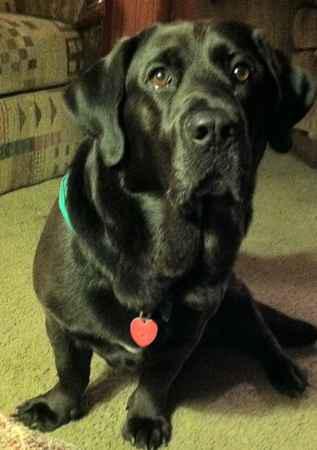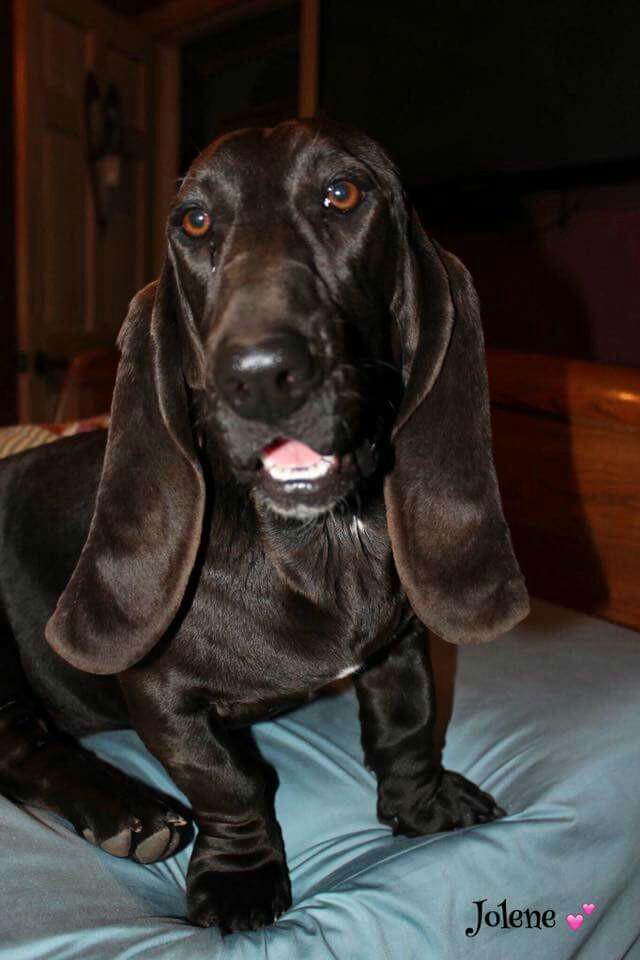The first image is the image on the left, the second image is the image on the right. For the images shown, is this caption "One of the dogs is sitting on or lying next to a pillow." true? Answer yes or no. Yes. The first image is the image on the left, the second image is the image on the right. For the images displayed, is the sentence "There is a black dog in the center of both images." factually correct? Answer yes or no. Yes. 